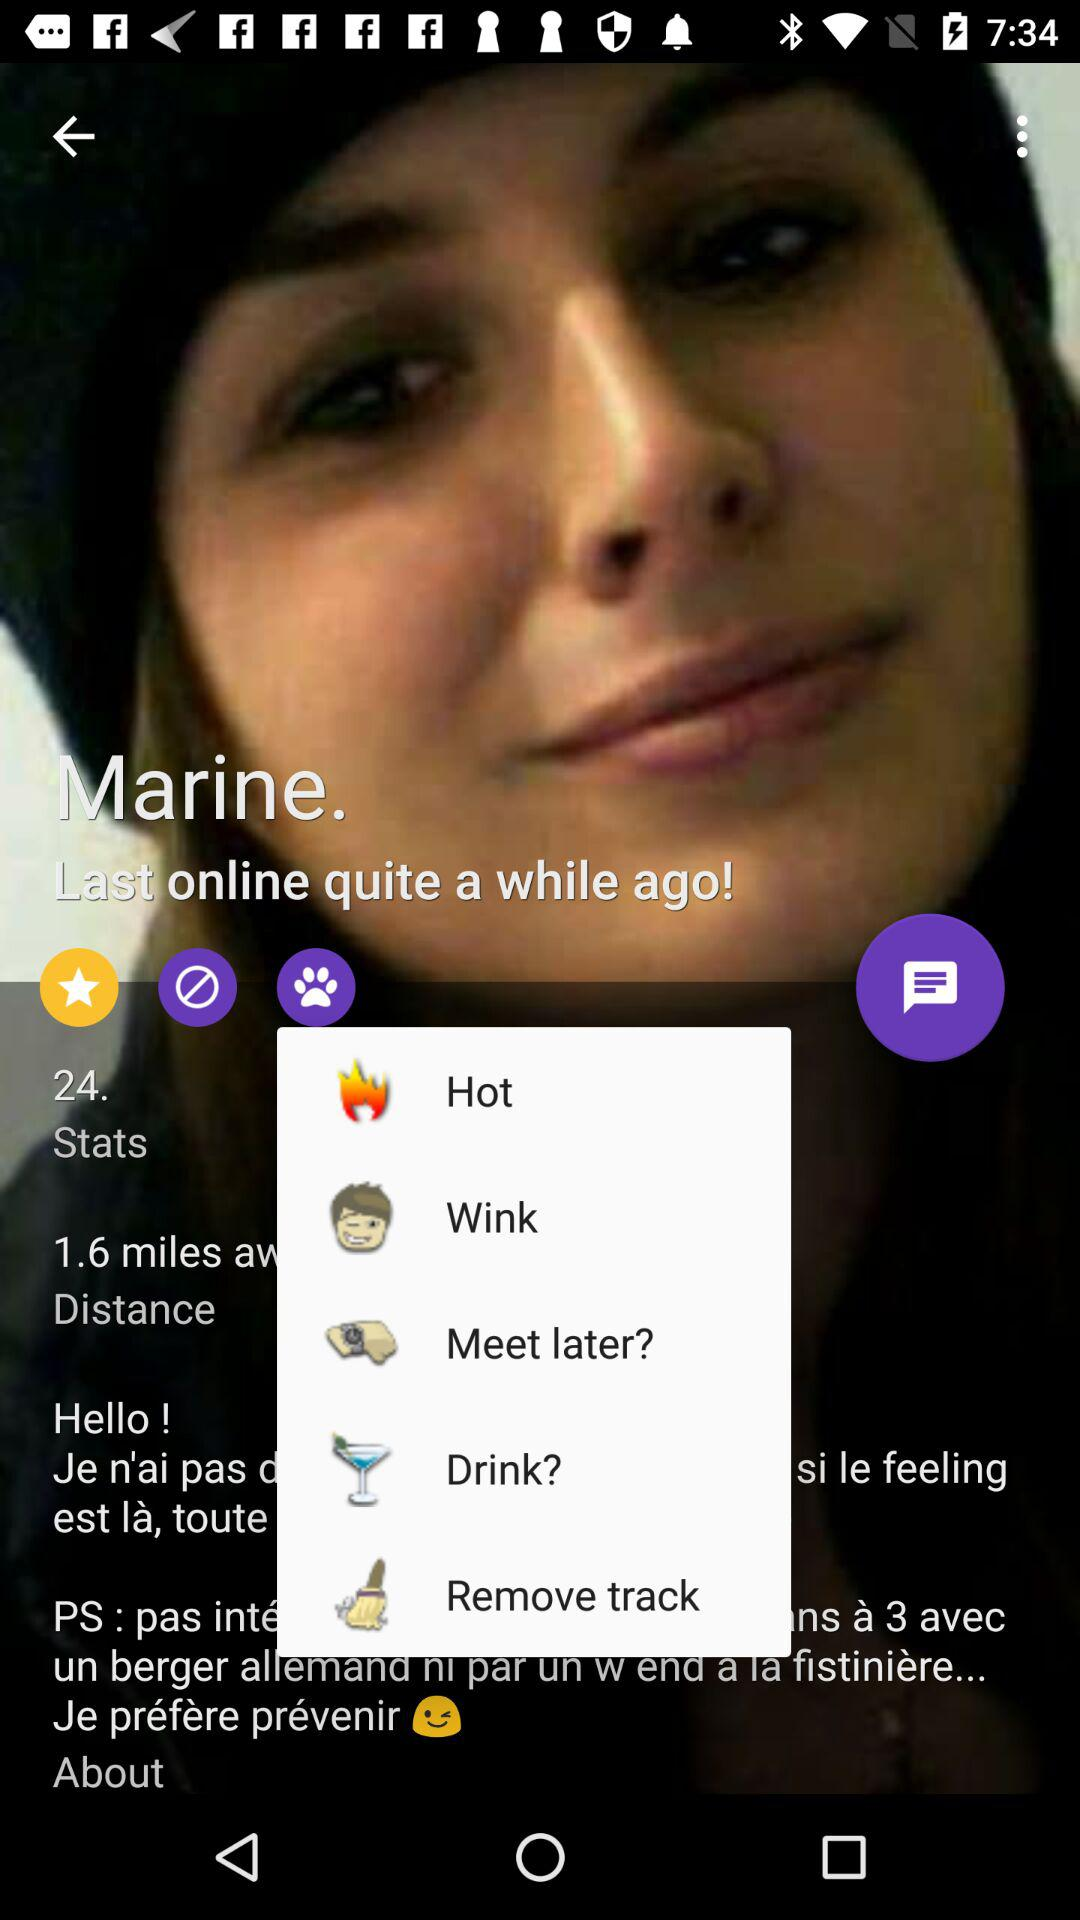What is the distance shown there? The shown distance is 1.6 miles. 